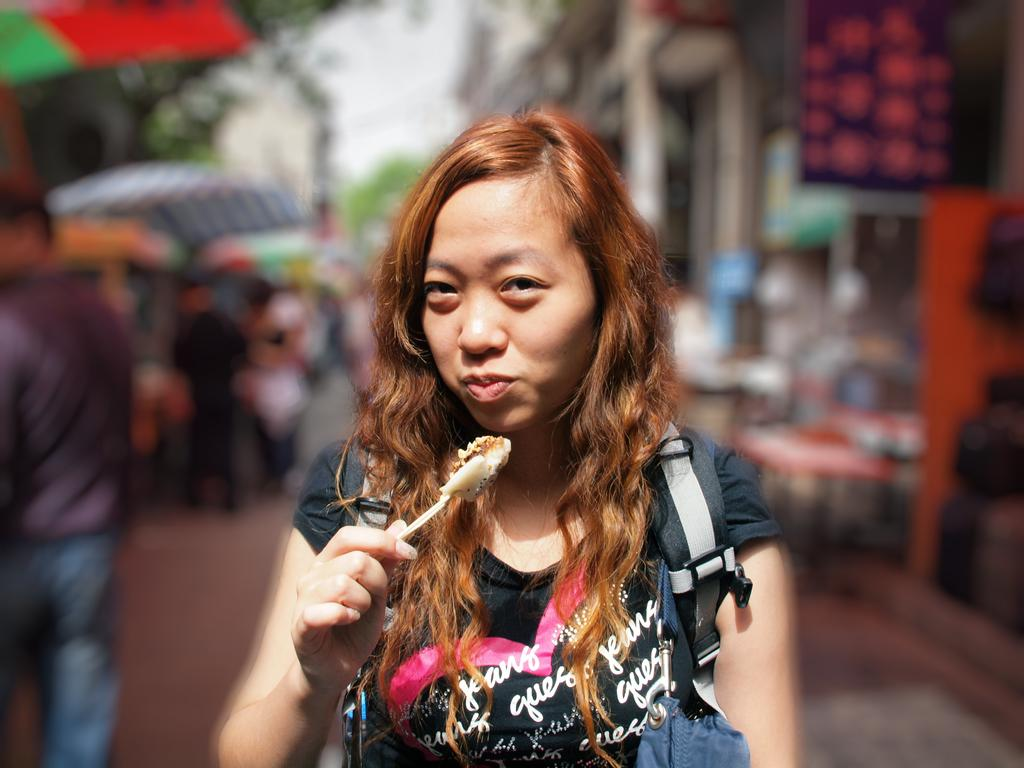What is the main subject of the image? There is a woman standing in the image. What is the woman holding in the image? The woman is holding a food item. Are there any other people in the image besides the woman? Yes, there are people standing in the image. Can you describe the background of the image? The background of the image is blurred. What type of ghost can be seen interacting with the woman in the image? There is no ghost present in the image; it only features a woman holding a food item and other people standing. How many oranges are visible in the image? There are no oranges present in the image. 